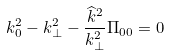<formula> <loc_0><loc_0><loc_500><loc_500>k _ { 0 } ^ { 2 } - k _ { \perp } ^ { 2 } - \frac { \widehat { k } ^ { 2 } } { k _ { \bot } ^ { 2 } } \Pi _ { 0 0 } = 0</formula> 